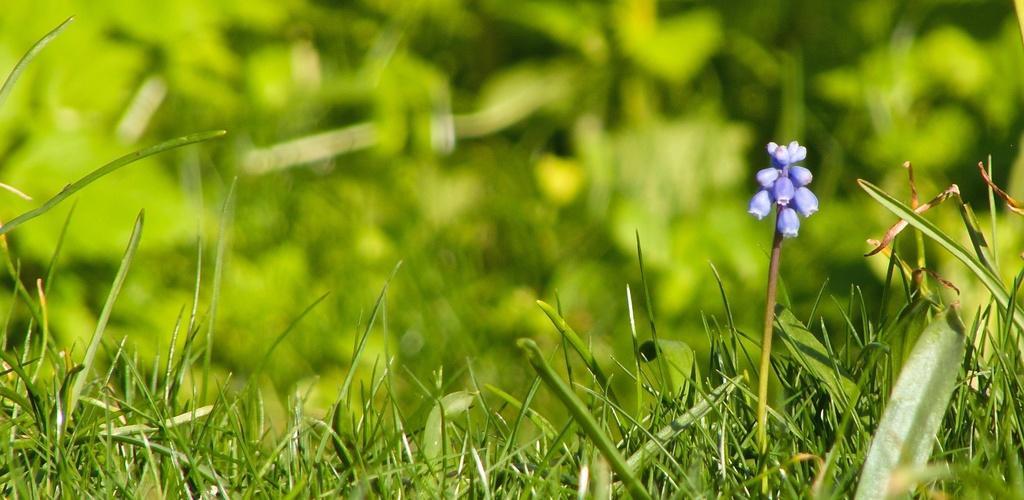Please provide a concise description of this image. In this image we can see the plants with buds and blur background. 